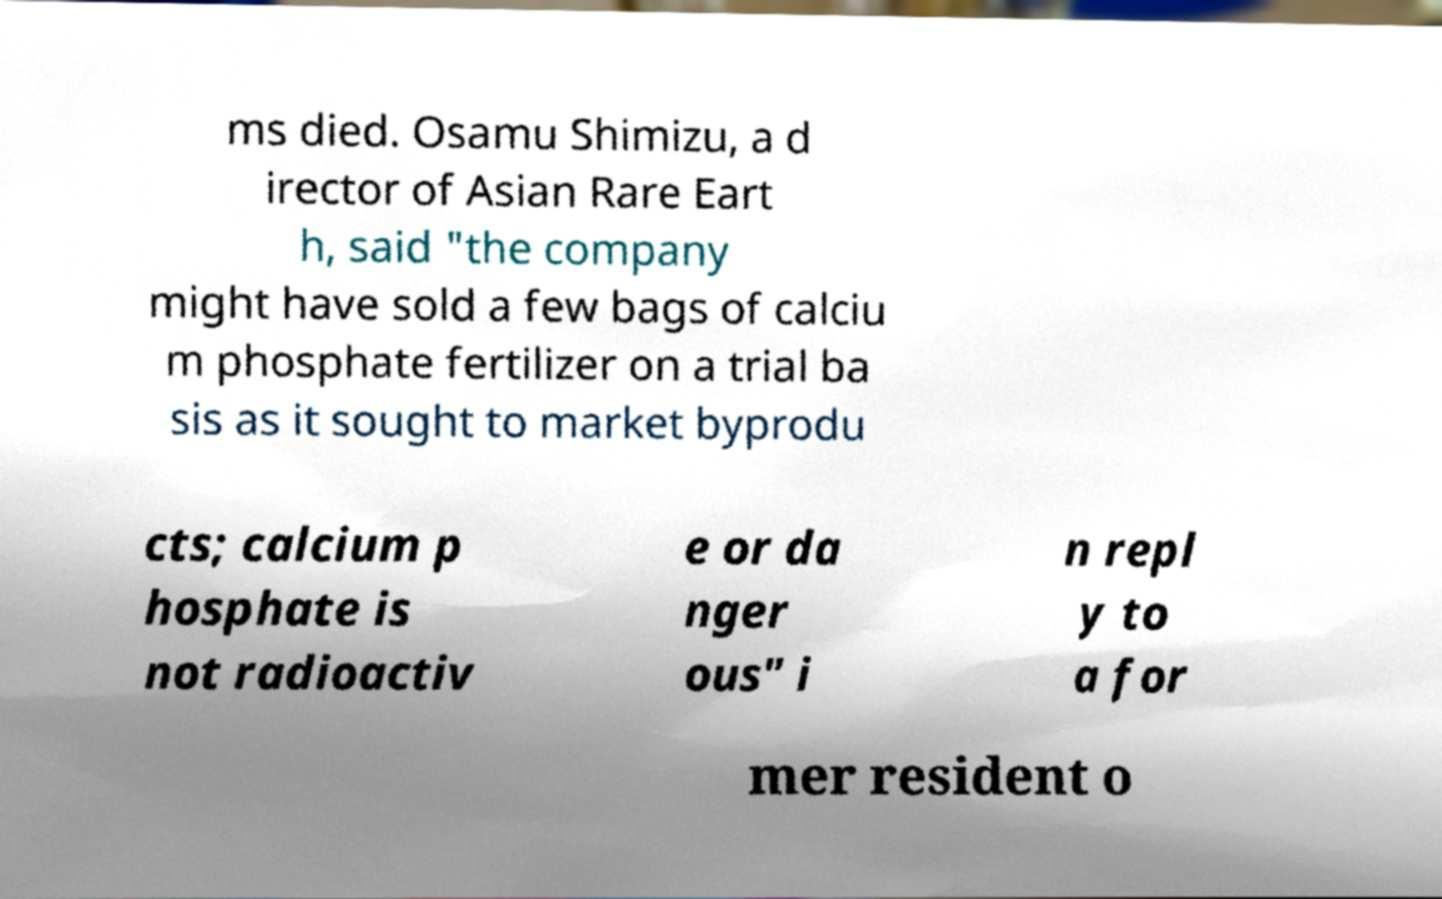There's text embedded in this image that I need extracted. Can you transcribe it verbatim? ms died. Osamu Shimizu, a d irector of Asian Rare Eart h, said "the company might have sold a few bags of calciu m phosphate fertilizer on a trial ba sis as it sought to market byprodu cts; calcium p hosphate is not radioactiv e or da nger ous" i n repl y to a for mer resident o 